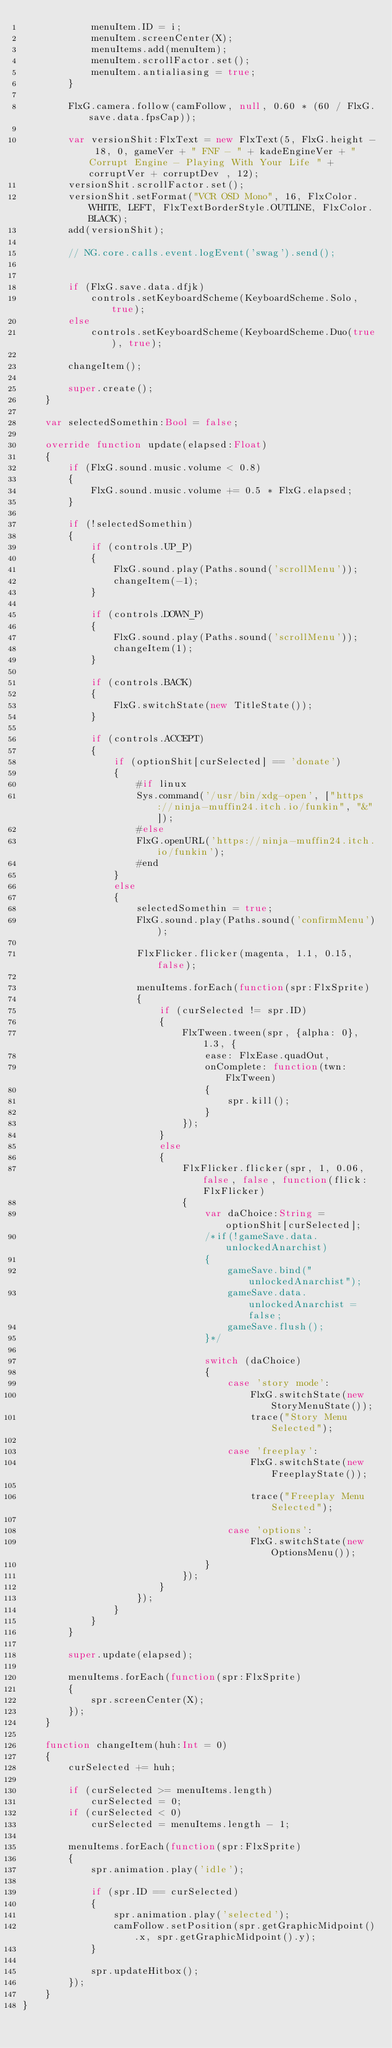Convert code to text. <code><loc_0><loc_0><loc_500><loc_500><_Haxe_>			menuItem.ID = i;
			menuItem.screenCenter(X);
			menuItems.add(menuItem);
			menuItem.scrollFactor.set();
			menuItem.antialiasing = true;
		}

		FlxG.camera.follow(camFollow, null, 0.60 * (60 / FlxG.save.data.fpsCap));

		var versionShit:FlxText = new FlxText(5, FlxG.height - 18, 0, gameVer + " FNF - " + kadeEngineVer + "Corrupt Engine - Playing With Your Life " + corruptVer + corruptDev , 12);
		versionShit.scrollFactor.set();
		versionShit.setFormat("VCR OSD Mono", 16, FlxColor.WHITE, LEFT, FlxTextBorderStyle.OUTLINE, FlxColor.BLACK);
		add(versionShit);

		// NG.core.calls.event.logEvent('swag').send();


		if (FlxG.save.data.dfjk)
			controls.setKeyboardScheme(KeyboardScheme.Solo, true);
		else
			controls.setKeyboardScheme(KeyboardScheme.Duo(true), true);

		changeItem();

		super.create();
	}

	var selectedSomethin:Bool = false;

	override function update(elapsed:Float)
	{
		if (FlxG.sound.music.volume < 0.8)
		{
			FlxG.sound.music.volume += 0.5 * FlxG.elapsed;
		}

		if (!selectedSomethin)
		{
			if (controls.UP_P)
			{
				FlxG.sound.play(Paths.sound('scrollMenu'));
				changeItem(-1);
			}

			if (controls.DOWN_P)
			{
				FlxG.sound.play(Paths.sound('scrollMenu'));
				changeItem(1);
			}

			if (controls.BACK)
			{
				FlxG.switchState(new TitleState());
			}

			if (controls.ACCEPT)
			{
				if (optionShit[curSelected] == 'donate')
				{
					#if linux
					Sys.command('/usr/bin/xdg-open', ["https://ninja-muffin24.itch.io/funkin", "&"]);
					#else
					FlxG.openURL('https://ninja-muffin24.itch.io/funkin');
					#end
				}
				else
				{
					selectedSomethin = true;
					FlxG.sound.play(Paths.sound('confirmMenu'));

					FlxFlicker.flicker(magenta, 1.1, 0.15, false);

					menuItems.forEach(function(spr:FlxSprite)
					{
						if (curSelected != spr.ID)
						{
							FlxTween.tween(spr, {alpha: 0}, 1.3, {
								ease: FlxEase.quadOut,
								onComplete: function(twn:FlxTween)
								{
									spr.kill();
								}
							});
						}
						else
						{
							FlxFlicker.flicker(spr, 1, 0.06, false, false, function(flick:FlxFlicker)
							{
								var daChoice:String = optionShit[curSelected];
								/*if(!gameSave.data.unlockedAnarchist)
								{
									gameSave.bind("unlockedAnarchist");
									gameSave.data.unlockedAnarchist = false;
									gameSave.flush();
								}*/

								switch (daChoice)
								{
									case 'story mode':
										FlxG.switchState(new StoryMenuState());
										trace("Story Menu Selected");
										
									case 'freeplay':
										FlxG.switchState(new FreeplayState());

										trace("Freeplay Menu Selected");

									case 'options':
										FlxG.switchState(new OptionsMenu());
								}
							});
						}
					});
				}
			}
		}

		super.update(elapsed);

		menuItems.forEach(function(spr:FlxSprite)
		{
			spr.screenCenter(X);
		});
	}

	function changeItem(huh:Int = 0)
	{
		curSelected += huh;

		if (curSelected >= menuItems.length)
			curSelected = 0;
		if (curSelected < 0)
			curSelected = menuItems.length - 1;

		menuItems.forEach(function(spr:FlxSprite)
		{
			spr.animation.play('idle');

			if (spr.ID == curSelected)
			{
				spr.animation.play('selected');
				camFollow.setPosition(spr.getGraphicMidpoint().x, spr.getGraphicMidpoint().y);
			}

			spr.updateHitbox();
		});
	}
}
</code> 